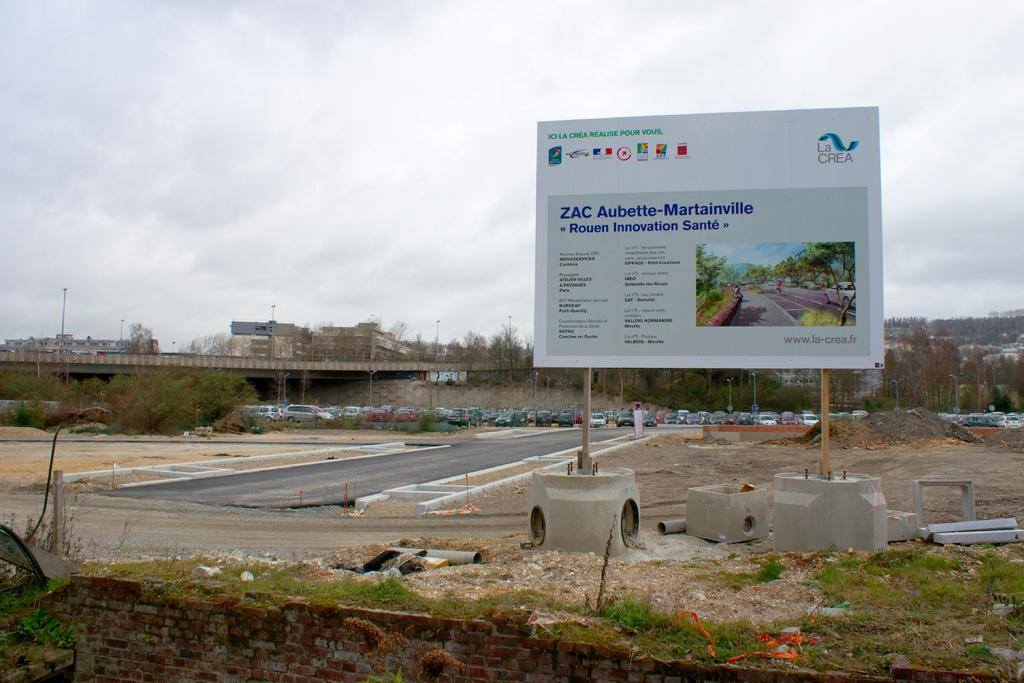Provide a one-sentence caption for the provided image. A big white sign that says ZAC on a construction site. 